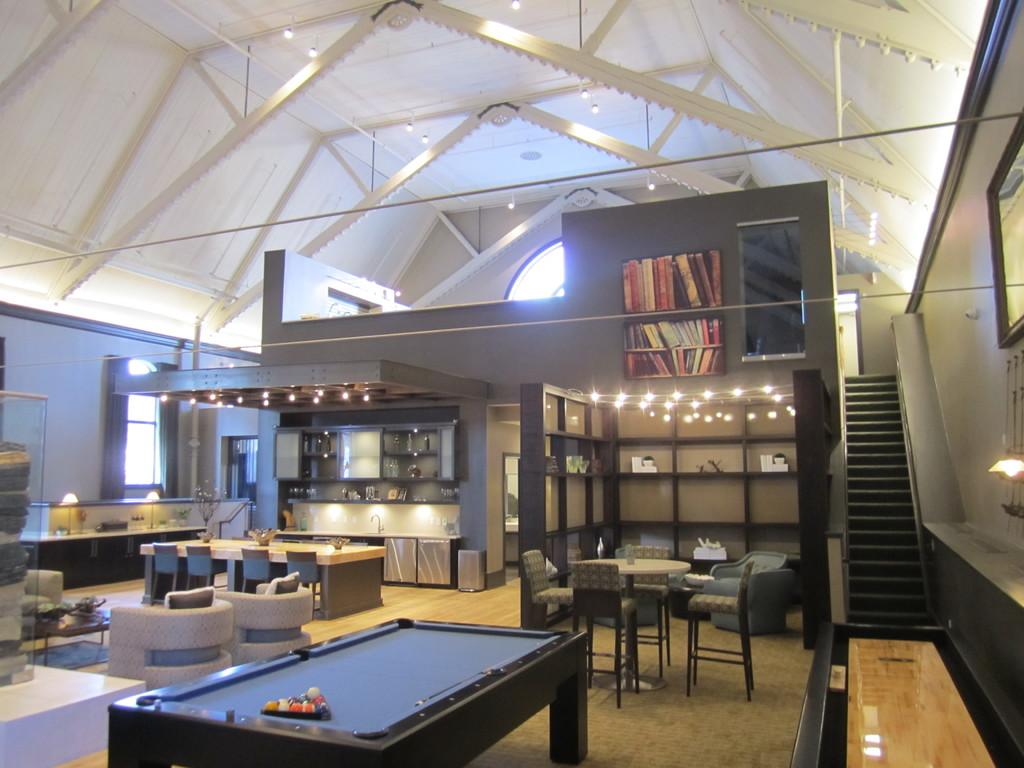Where is the setting of the image? The image is inside a room. What type of furniture is present in the room? There is a billiards table, a dining table with chairs, and a sofa in the room. Are there any architectural features in the room? Yes, there are stairs in the room. What else can be found in the room? There is a bookshelf and lights in the room. How many pets are visible in the image? There are no pets present in the image. What type of party is being held in the image? There is no party depicted in the image. 